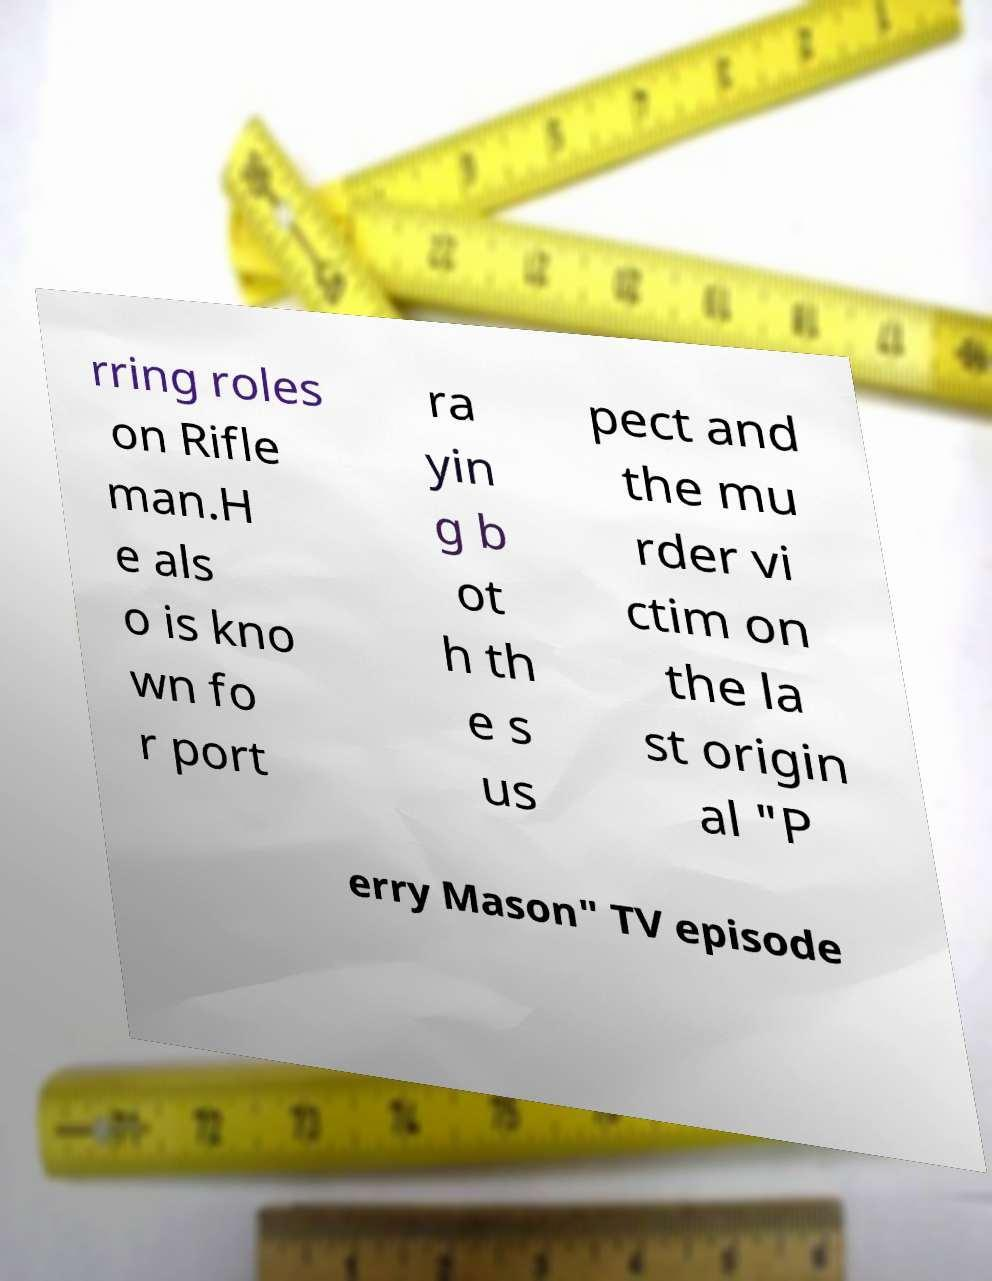For documentation purposes, I need the text within this image transcribed. Could you provide that? rring roles on Rifle man.H e als o is kno wn fo r port ra yin g b ot h th e s us pect and the mu rder vi ctim on the la st origin al "P erry Mason" TV episode 